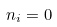Convert formula to latex. <formula><loc_0><loc_0><loc_500><loc_500>n _ { i } = 0</formula> 